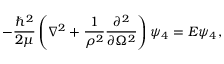Convert formula to latex. <formula><loc_0><loc_0><loc_500><loc_500>- \frac { \hbar { ^ } { 2 } } { 2 \mu } \left ( \nabla ^ { 2 } + \frac { 1 } { \rho ^ { 2 } } \frac { \partial ^ { 2 } } { \partial \Omega ^ { 2 } } \right ) \psi _ { 4 } = E \psi _ { 4 } ,</formula> 